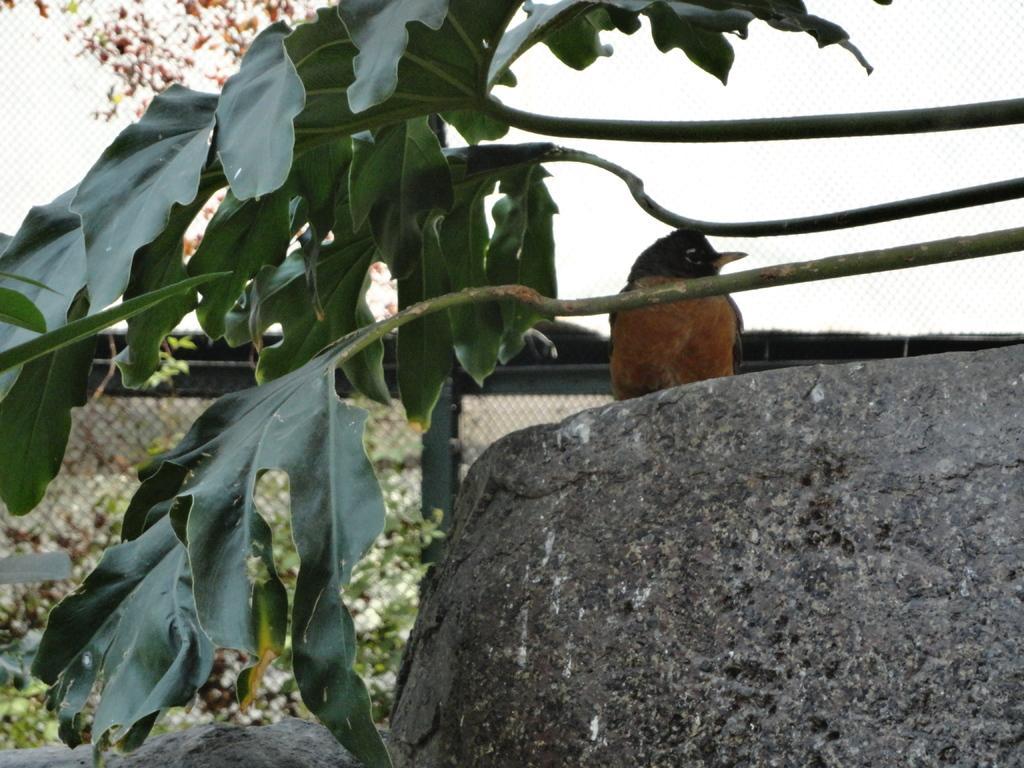How would you summarize this image in a sentence or two? In this image there is a bird sitting on a rock and there are leaves, in the background there is a fencing and a plant. 